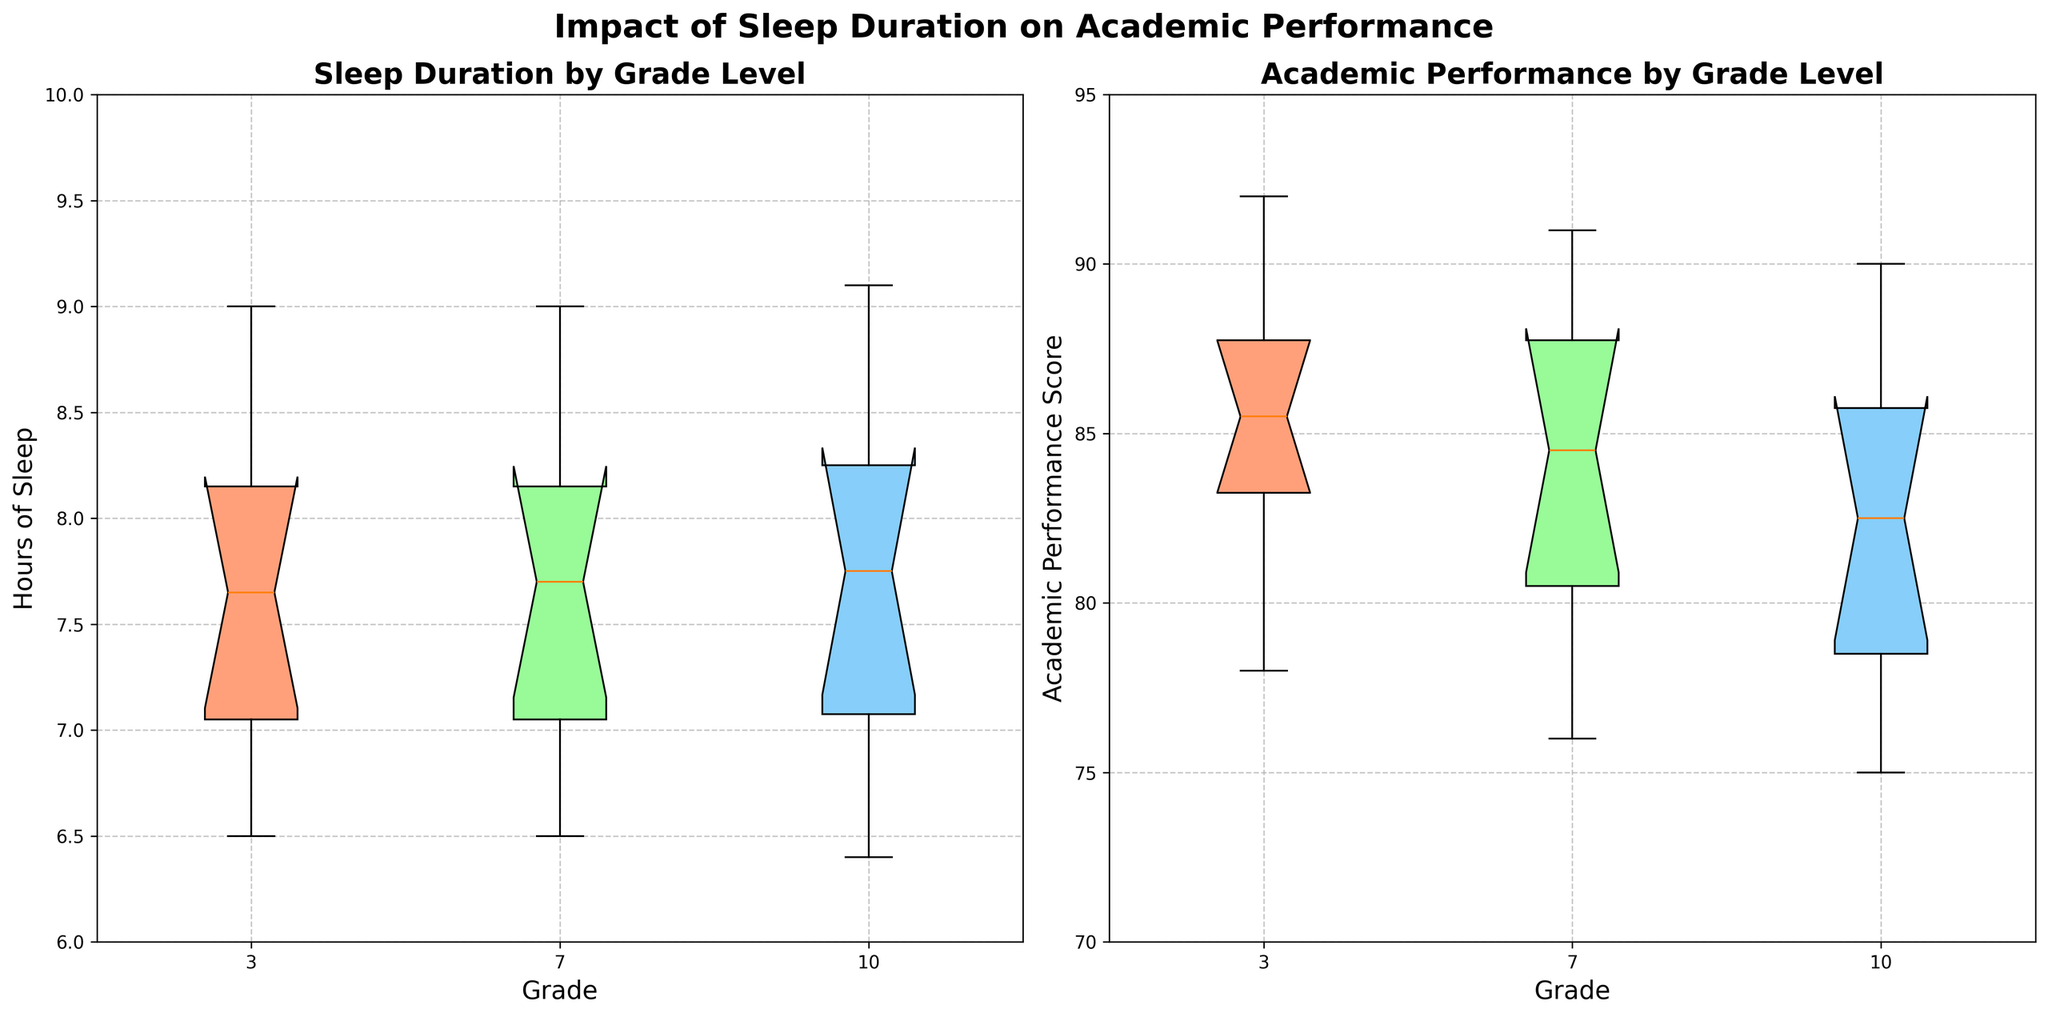How many box plots are displayed in total? There are two box plots displayed side by side in the figure. One shows sleep duration by grade level, and the other shows academic performance by grade level.
Answer: 2 What grades are represented in the box plots? Both box plots display data for the same grades, which are indicated by the labels along the x-axes. The grades represented are 3, 7, and 10.
Answer: 3, 7, 10 What does the notch in a notched box plot represent? The notch in a notched box plot represents the confidence interval around the median. If the notches of two box plots do not overlap, this suggests that the medians are significantly different.
Answer: Confidence interval around the median Which grade has the highest median hours of sleep? By examining the median values indicated by the central horizontal lines within each box in the sleep duration box plot, we can see that Grade 10 has the highest median hours of sleep.
Answer: Grade 10 How does the range of academic performance scores compare across the three grades? The range of academic performance scores within each grade can be determined by looking at the lengths of the whiskers. Grade 7 has the widest range, followed by Grade 10, with Grade 3 having the smallest range.
Answer: Grade 7 > Grade 10 > Grade 3 Which grade has the most variability in sleep duration? The variability in sleep duration is indicated by the length of the box as well as the whiskers. Grade 7 has the most variability in sleep duration, as its interquartile range (IQR) and whiskers cover a wider range of sleep hours than the other grades.
Answer: Grade 7 Is there a grade where the students' lower quartile of academic performance is higher than the students' median performance in another grade? By comparing the lower quartile of each grade to the medians of the others, we can see that the lower quartile for Grade 3's academic performance is higher than the median performance in Grade 7.
Answer: Yes Which box plot indicates a possible outlier? Outliers are typically indicated by data points outside the whiskers. In the sleep duration box plot, Grade 10 shows a possible outlier on the lower end of the distribution.
Answer: Sleep Duration, Grade 10 Do all grades show an improvement in academic performance with increased sleep duration? To conclude this, one would examine the overall trend between sleep duration and academic performance across the grades. The box plots show that higher medians in sleep duration generally correlate with higher median academic performance, supporting this statement.
Answer: Yes, generally For which grade are the interquartile ranges (IQR) of sleep duration and academic performance the smallest? To find the smallest IQR, we compare the lengths of the boxes (representing the IQR) in each plot. For Grade 3, both the sleep duration and academic performance boxes are relatively narrow, indicating the smallest IQR.
Answer: Grade 3 